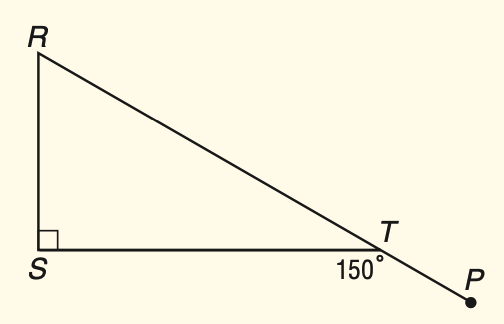Question: \triangle R S T is a right triangle. Find m \angle R.
Choices:
A. 30
B. 40
C. 50
D. 60
Answer with the letter. Answer: D 